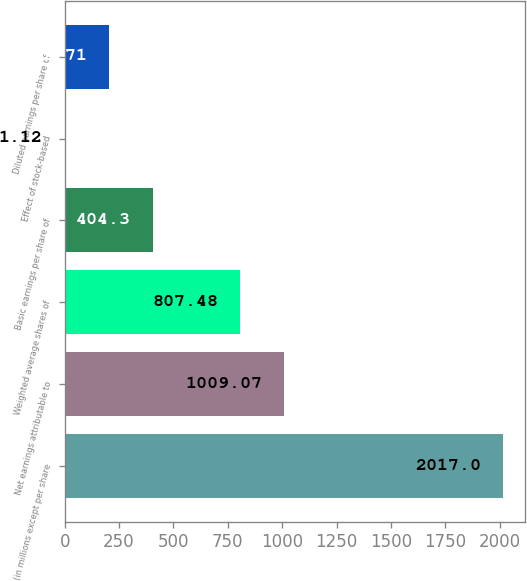<chart> <loc_0><loc_0><loc_500><loc_500><bar_chart><fcel>(in millions except per share<fcel>Net earnings attributable to<fcel>Weighted average shares of<fcel>Basic earnings per share of<fcel>Effect of stock-based<fcel>Diluted earnings per share of<nl><fcel>2017<fcel>1009.07<fcel>807.48<fcel>404.3<fcel>1.12<fcel>202.71<nl></chart> 